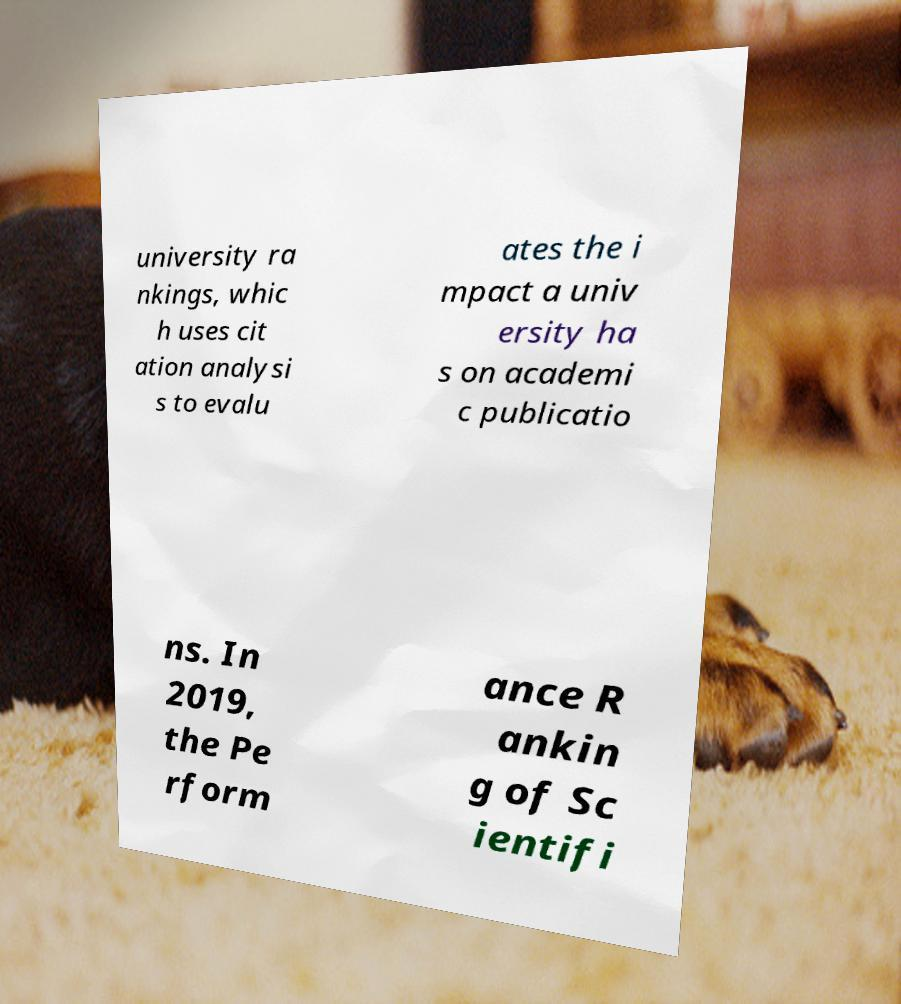What messages or text are displayed in this image? I need them in a readable, typed format. university ra nkings, whic h uses cit ation analysi s to evalu ates the i mpact a univ ersity ha s on academi c publicatio ns. In 2019, the Pe rform ance R ankin g of Sc ientifi 